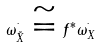Convert formula to latex. <formula><loc_0><loc_0><loc_500><loc_500>\omega ^ { ^ { . } } _ { \tilde { X } } \cong f ^ { * } \omega ^ { ^ { . } } _ { X }</formula> 